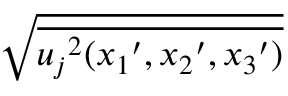<formula> <loc_0><loc_0><loc_500><loc_500>\sqrt { \overline { { { u _ { j } } ^ { 2 } ( { x _ { 1 } } ^ { \prime } , { x _ { 2 } } ^ { \prime } , { x _ { 3 } } ^ { \prime } ) } } }</formula> 